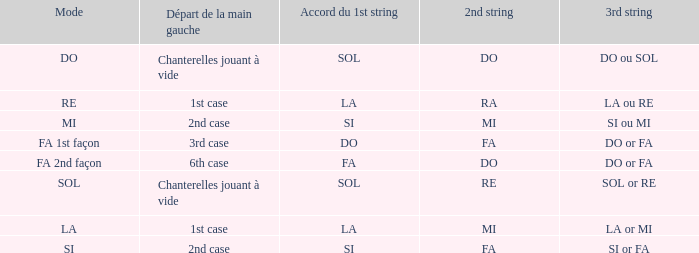What is the left-hand start for the 2nd string of ra? 1st case. 